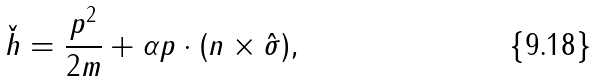Convert formula to latex. <formula><loc_0><loc_0><loc_500><loc_500>\check { h } = \frac { { p } ^ { 2 } } { 2 m } + \alpha { p } \cdot ( { n } \times { \hat { \sigma } } ) ,</formula> 